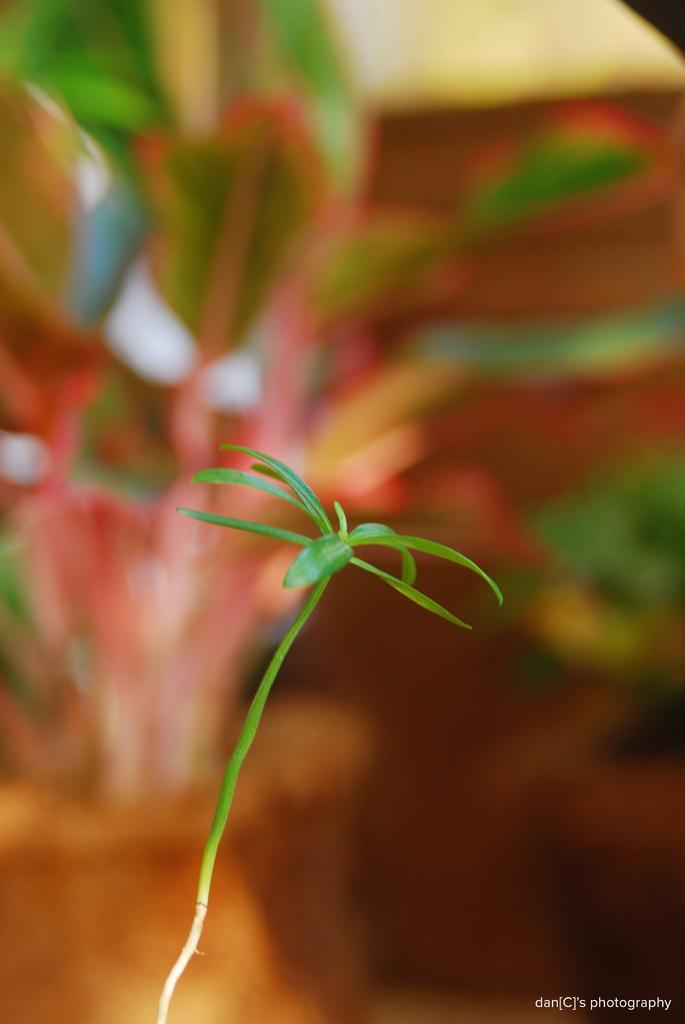What is present in the image? There is a plant in the image. Can you describe the background of the image? The background of the image is blurred. Is there any additional information or marking on the image? Yes, there is a watermark on the image. Can you see the bee buzzing around the plant in the image? There is no bee present in the image; it only features a plant. Where did the person take the vacation where they took this picture of the plant? The provided facts do not mention any information about a vacation or the location of the image. 